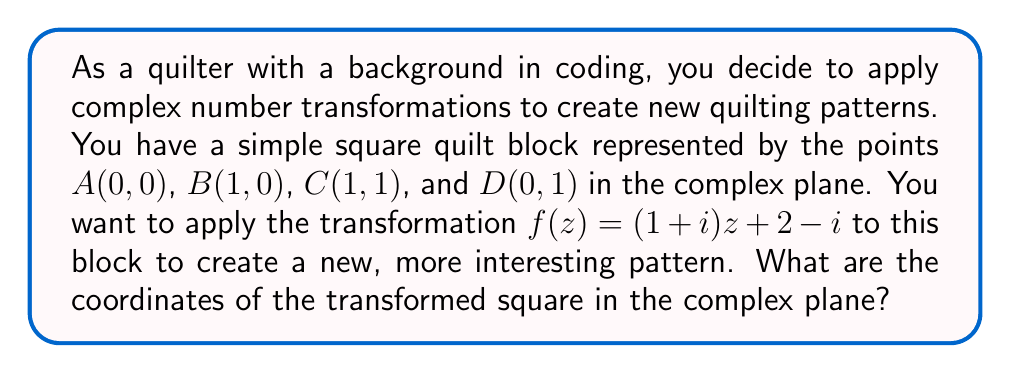Can you answer this question? Let's approach this step-by-step:

1) First, we need to represent our original points as complex numbers:
   $A = 0 + 0i = 0$
   $B = 1 + 0i = 1$
   $C = 1 + 1i$
   $D = 0 + 1i = i$

2) The transformation function is $f(z) = (1+i)z + 2-i$. We need to apply this to each point.

3) For point A:
   $f(0) = (1+i)(0) + 2-i = 2-i$

4) For point B:
   $f(1) = (1+i)(1) + 2-i = 1+i+2-i = 3$

5) For point C:
   $f(1+i) = (1+i)(1+i) + 2-i$
            $= 1+i+i+i^2 + 2-i$
            $= 1+i+i-1 + 2-i$
            $= 2+i$

6) For point D:
   $f(i) = (1+i)(i) + 2-i$
          $= i+i^2 + 2-i$
          $= i-1 + 2-i$
          $= 1$

Therefore, the transformed square has vertices at:
$A'(2,-1)$, $B'(3,0)$, $C'(2,1)$, and $D'(1,0)$ in the complex plane.

[asy]
import geometry;

unitsize(1cm);

pair A = (0,0);
pair B = (1,0);
pair C = (1,1);
pair D = (0,1);

pair Ap = (2,-1);
pair Bp = (3,0);
pair Cp = (2,1);
pair Dp = (1,0);

draw(A--B--C--D--cycle, blue);
draw(Ap--Bp--Cp--Dp--cycle, red);

label("A", A, SW);
label("B", B, SE);
label("C", C, NE);
label("D", D, NW);

label("A'", Ap, SW);
label("B'", Bp, SE);
label("C'", Cp, NE);
label("D'", Dp, NW);

[/asy]
Answer: The transformed square has vertices at $A'(2,-1)$, $B'(3,0)$, $C'(2,1)$, and $D'(1,0)$ in the complex plane. 